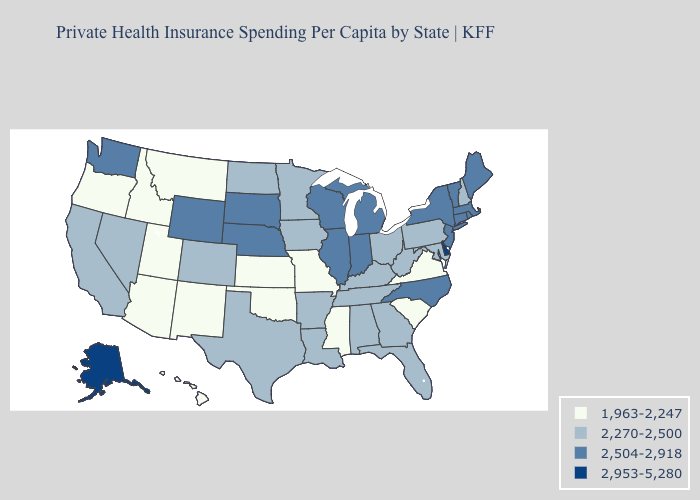Among the states that border Washington , which have the highest value?
Keep it brief. Idaho, Oregon. What is the lowest value in the Northeast?
Answer briefly. 2,270-2,500. Name the states that have a value in the range 2,504-2,918?
Write a very short answer. Connecticut, Illinois, Indiana, Maine, Massachusetts, Michigan, Nebraska, New Jersey, New York, North Carolina, Rhode Island, South Dakota, Vermont, Washington, Wisconsin, Wyoming. What is the value of South Dakota?
Concise answer only. 2,504-2,918. Name the states that have a value in the range 2,270-2,500?
Short answer required. Alabama, Arkansas, California, Colorado, Florida, Georgia, Iowa, Kentucky, Louisiana, Maryland, Minnesota, Nevada, New Hampshire, North Dakota, Ohio, Pennsylvania, Tennessee, Texas, West Virginia. Name the states that have a value in the range 1,963-2,247?
Answer briefly. Arizona, Hawaii, Idaho, Kansas, Mississippi, Missouri, Montana, New Mexico, Oklahoma, Oregon, South Carolina, Utah, Virginia. Name the states that have a value in the range 2,270-2,500?
Write a very short answer. Alabama, Arkansas, California, Colorado, Florida, Georgia, Iowa, Kentucky, Louisiana, Maryland, Minnesota, Nevada, New Hampshire, North Dakota, Ohio, Pennsylvania, Tennessee, Texas, West Virginia. What is the value of Massachusetts?
Concise answer only. 2,504-2,918. What is the lowest value in the USA?
Short answer required. 1,963-2,247. Name the states that have a value in the range 2,270-2,500?
Short answer required. Alabama, Arkansas, California, Colorado, Florida, Georgia, Iowa, Kentucky, Louisiana, Maryland, Minnesota, Nevada, New Hampshire, North Dakota, Ohio, Pennsylvania, Tennessee, Texas, West Virginia. What is the value of Minnesota?
Quick response, please. 2,270-2,500. Does Oklahoma have the lowest value in the South?
Write a very short answer. Yes. Name the states that have a value in the range 1,963-2,247?
Answer briefly. Arizona, Hawaii, Idaho, Kansas, Mississippi, Missouri, Montana, New Mexico, Oklahoma, Oregon, South Carolina, Utah, Virginia. What is the lowest value in the USA?
Short answer required. 1,963-2,247. Name the states that have a value in the range 1,963-2,247?
Give a very brief answer. Arizona, Hawaii, Idaho, Kansas, Mississippi, Missouri, Montana, New Mexico, Oklahoma, Oregon, South Carolina, Utah, Virginia. 